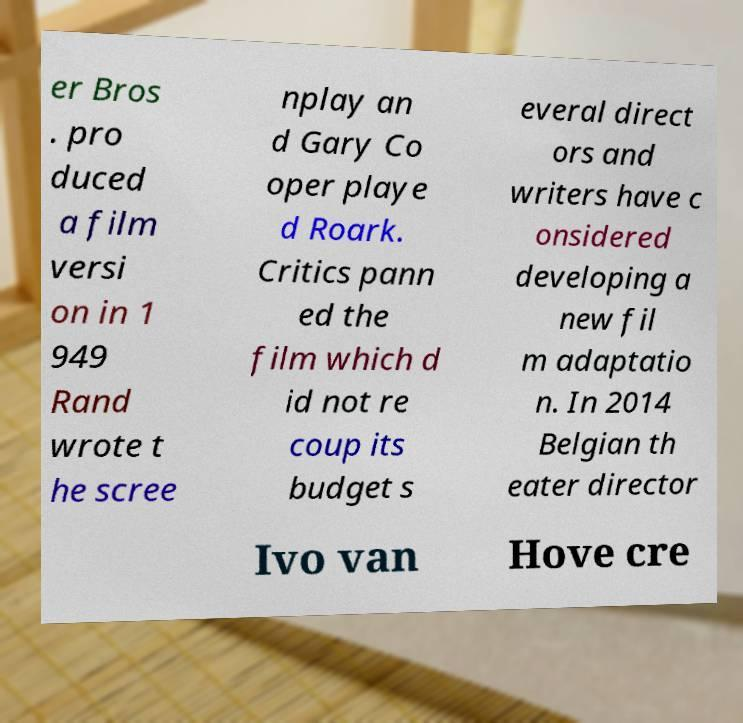Please read and relay the text visible in this image. What does it say? er Bros . pro duced a film versi on in 1 949 Rand wrote t he scree nplay an d Gary Co oper playe d Roark. Critics pann ed the film which d id not re coup its budget s everal direct ors and writers have c onsidered developing a new fil m adaptatio n. In 2014 Belgian th eater director Ivo van Hove cre 